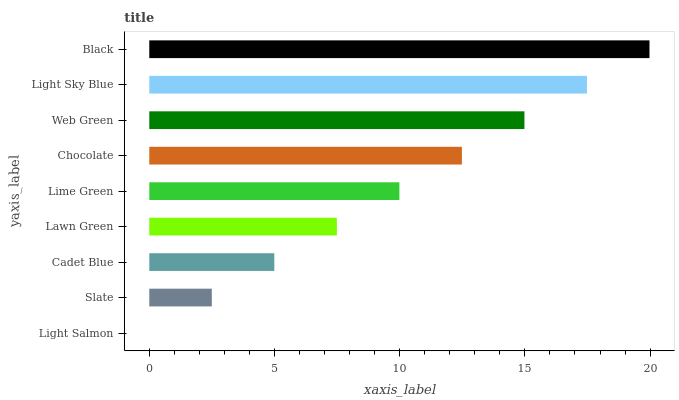Is Light Salmon the minimum?
Answer yes or no. Yes. Is Black the maximum?
Answer yes or no. Yes. Is Slate the minimum?
Answer yes or no. No. Is Slate the maximum?
Answer yes or no. No. Is Slate greater than Light Salmon?
Answer yes or no. Yes. Is Light Salmon less than Slate?
Answer yes or no. Yes. Is Light Salmon greater than Slate?
Answer yes or no. No. Is Slate less than Light Salmon?
Answer yes or no. No. Is Lime Green the high median?
Answer yes or no. Yes. Is Lime Green the low median?
Answer yes or no. Yes. Is Chocolate the high median?
Answer yes or no. No. Is Light Salmon the low median?
Answer yes or no. No. 